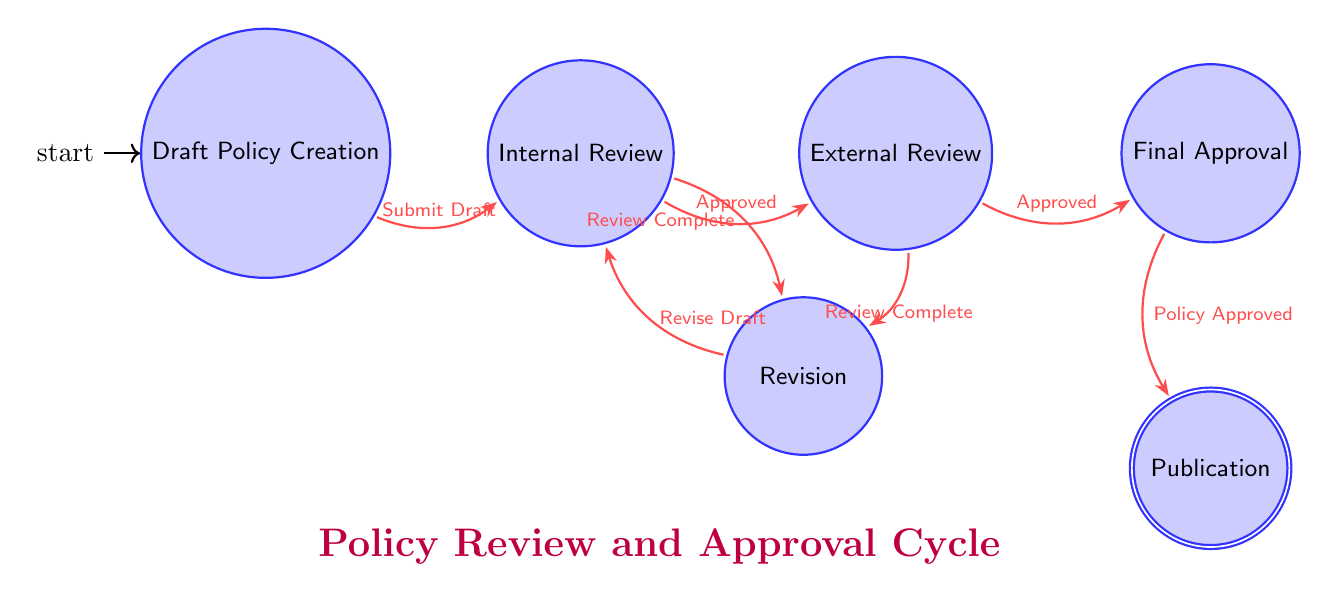What is the first state in the policy review cycle? The first state in the policy review cycle is explicitly labeled as "Draft Policy Creation." This node represents the beginning of the process where the initial draft is created.
Answer: Draft Policy Creation How many states are in the diagram? To find the total number of states, we can count each labeled node in the diagram, which are Draft Policy Creation, Internal Review, Revision, External Review, Final Approval, and Publication. This gives us a total of six states.
Answer: 6 What action leads from Internal Review to Revision? The action that leads from Internal Review to the Revision state is "Review Complete." This indicates that the review process has concluded, prompting a revision based on the feedback.
Answer: Review Complete Which state comes after Final Approval? The state that immediately follows Final Approval, as indicated by the directed edge in the diagram, is Publication. This implies that once the policy is approved, it proceeds to the publication phase.
Answer: Publication What action must happen before a policy can move to External Review? Before transitioning to External Review, the policy must be marked as "Approved" from the Internal Review state. This signifies that the internal stakeholders are satisfied, allowing for an external review to occur.
Answer: Approved What is the last action in the policy review cycle? The final action in the policy review cycle is "Policy Approved," which occurs when the policy has reached the Final Approval state and is ready to be published. This indicates the completion of the approval process.
Answer: Policy Approved Describe the relationship between Revision and Internal Review. The relationship between Revision and Internal Review consists of two actions: if the author completes needed changes in Revision, they can return to Internal Review by taking the action "Revise Draft." Additionally, after Internal Review, if feedback prompts changes, the process may need to return to Revision based on the "Review Complete" action.
Answer: Revise Draft and Review Complete How many transitions are depicted in the finite state machine? The total number of transitions can be counted by looking at the directed edges connecting the states, which include transitions from Draft to Internal, Internal to Revision, Internal to External, etc. Upon counting all transitions, we find that there are seven distinct transitions.
Answer: 7 